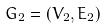<formula> <loc_0><loc_0><loc_500><loc_500>G _ { 2 } = ( V _ { 2 } , E _ { 2 } )</formula> 